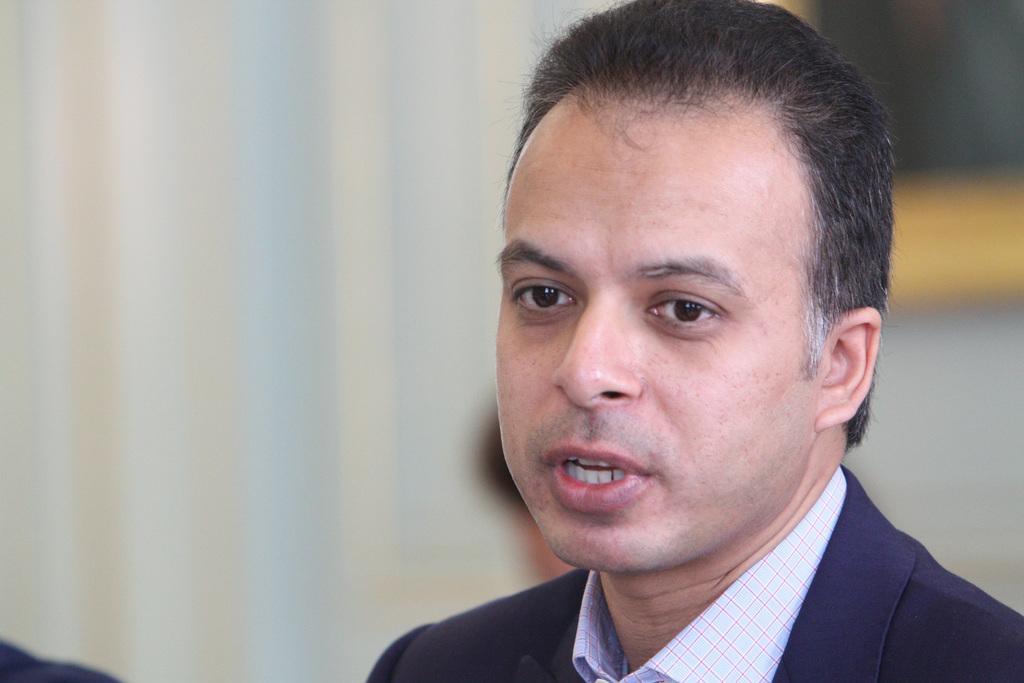Please provide a concise description of this image. There is a man wearing a navy blue coat. In the background it is blurred. 